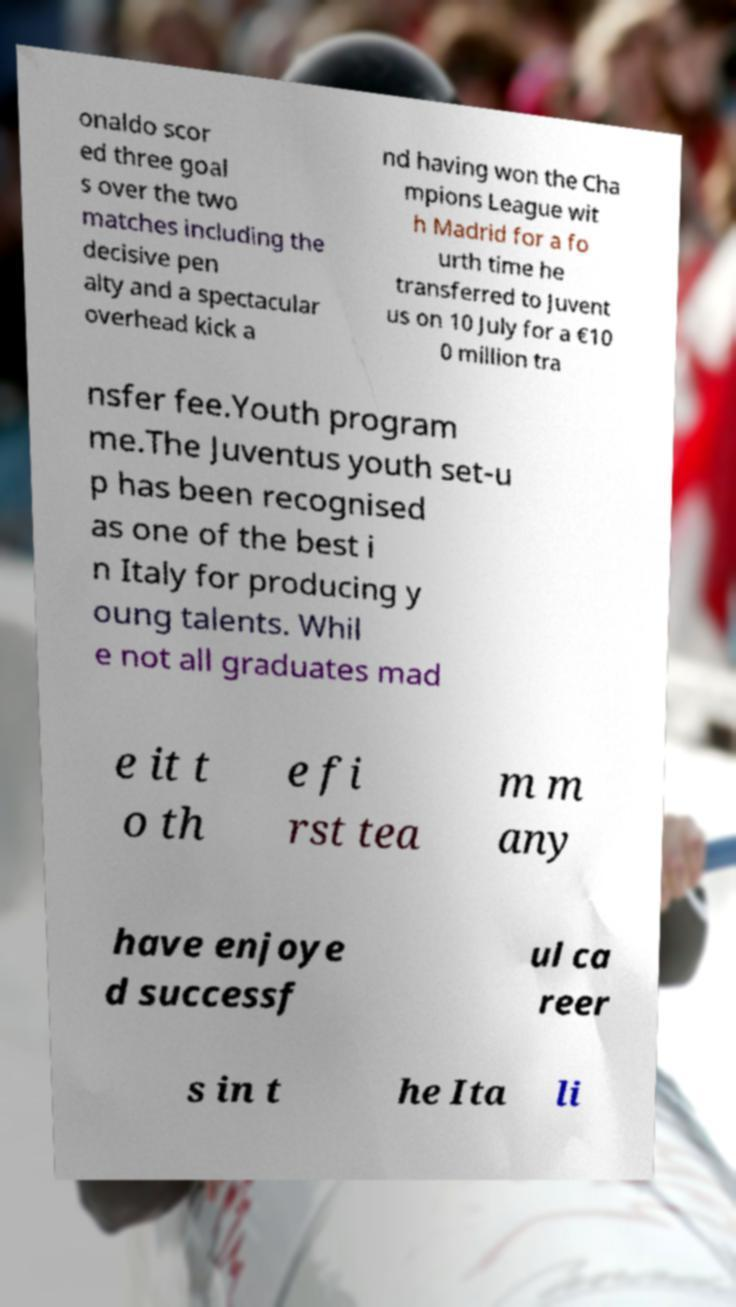Could you assist in decoding the text presented in this image and type it out clearly? onaldo scor ed three goal s over the two matches including the decisive pen alty and a spectacular overhead kick a nd having won the Cha mpions League wit h Madrid for a fo urth time he transferred to Juvent us on 10 July for a €10 0 million tra nsfer fee.Youth program me.The Juventus youth set-u p has been recognised as one of the best i n Italy for producing y oung talents. Whil e not all graduates mad e it t o th e fi rst tea m m any have enjoye d successf ul ca reer s in t he Ita li 